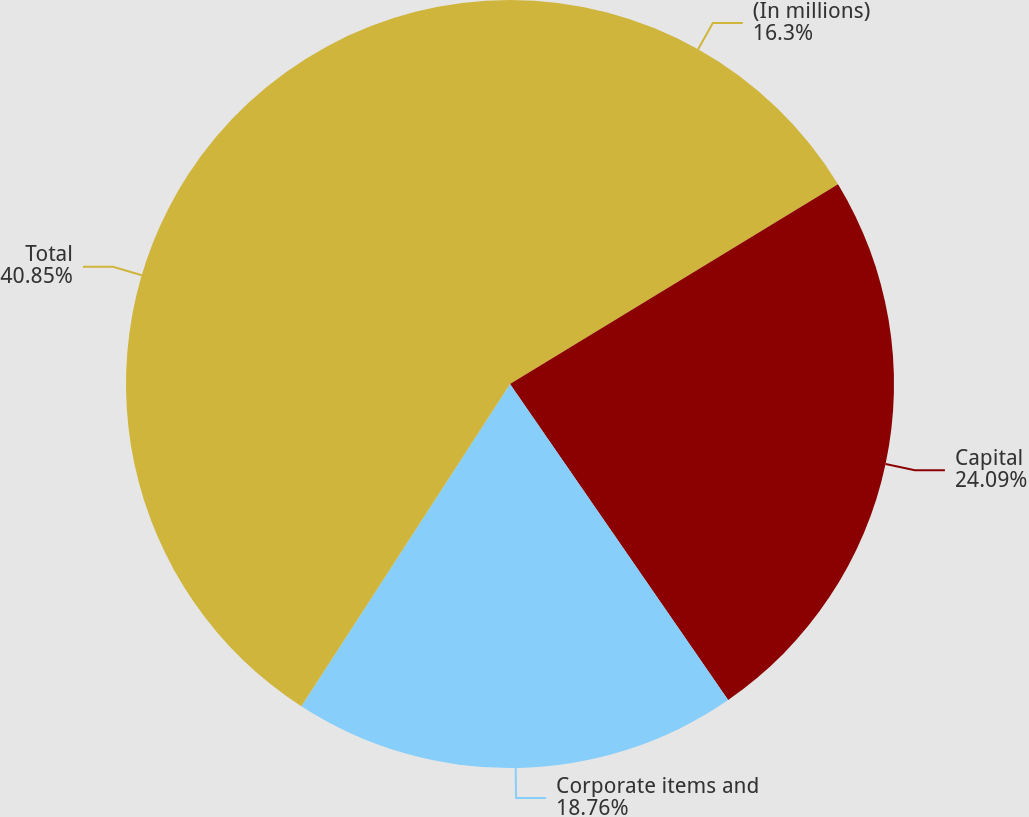Convert chart to OTSL. <chart><loc_0><loc_0><loc_500><loc_500><pie_chart><fcel>(In millions)<fcel>Capital<fcel>Corporate items and<fcel>Total<nl><fcel>16.3%<fcel>24.09%<fcel>18.76%<fcel>40.86%<nl></chart> 